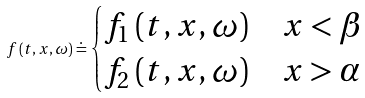<formula> <loc_0><loc_0><loc_500><loc_500>f \left ( t , x , \omega \right ) \doteq \begin{cases} f _ { 1 } \left ( t , x , \omega \right ) & x < \beta \\ f _ { 2 } \left ( t , x , \omega \right ) & x > \alpha \end{cases}</formula> 